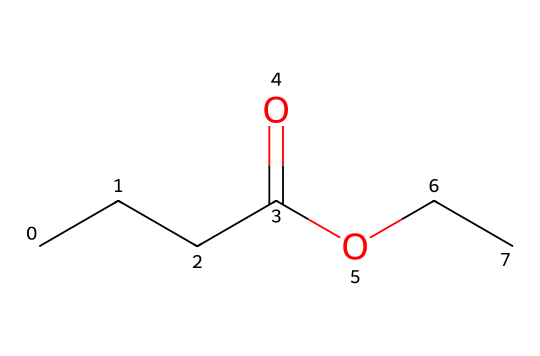what is the molecular formula of ethyl butyrate? To determine the molecular formula, we need to count the types of atoms in the SMILES representation. The structure has 5 carbon atoms (C), 10 hydrogen atoms (H), and 2 oxygen atoms (O), leading to the formula C5H10O2.
Answer: C5H10O2 how many carbon atoms are present in ethyl butyrate? In the SMILES representation, we can see there are five "C" characters that indicate the presence of five carbon atoms in the structure.
Answer: 5 what type of functional group is present in ethyl butyrate? By examining the SMILES, we identify that there is a carboxylate group (indicated by the presence of a carbonyl (C=O) and an ether (-O-) in the structure), characterizing it as an ester.
Answer: ester what is the primary characteristic that gives ethyl butyrate its pineapple scent? The presence of the ester functional group in ethyl butyrate is specifically associated with fruity and sweet aromas, which contributes to the pineapple scent.
Answer: ester how many hydrogen atoms are bonded to the central carbon atoms in ethyl butyrate? By analyzing the structure, we determine that the carbon atoms bond with hydrogen atoms to fulfill their tetravalency. The central carbon atoms typically bond with two to three hydrogen atoms, leading to a total of ten.
Answer: 10 what makes ethyl butyrate a common choice for air fresheners? Ethyl butyrate is chosen for air fresheners because of its fruity aroma profile, which resembles pineapple, appealing to many people. This scent is often associated with freshness and tropical areas.
Answer: fruity aroma 